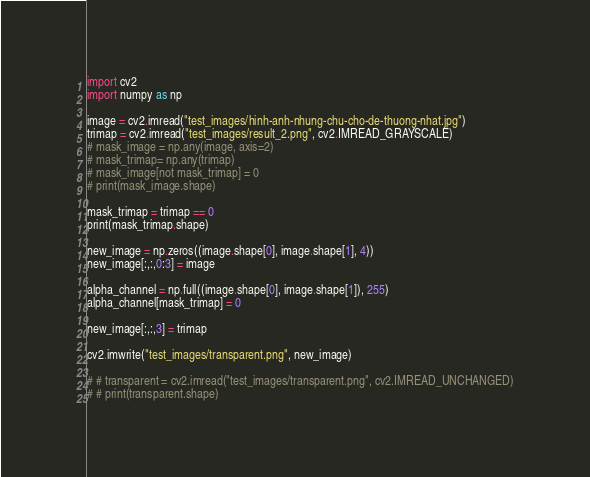Convert code to text. <code><loc_0><loc_0><loc_500><loc_500><_Python_>import cv2
import numpy as np

image = cv2.imread("test_images/hinh-anh-nhung-chu-cho-de-thuong-nhat.jpg")
trimap = cv2.imread("test_images/result_2.png", cv2.IMREAD_GRAYSCALE)
# mask_image = np.any(image, axis=2)
# mask_trimap= np.any(trimap)
# mask_image[not mask_trimap] = 0
# print(mask_image.shape)

mask_trimap = trimap == 0
print(mask_trimap.shape)

new_image = np.zeros((image.shape[0], image.shape[1], 4))
new_image[:,:,0:3] = image

alpha_channel = np.full((image.shape[0], image.shape[1]), 255)
alpha_channel[mask_trimap] = 0 

new_image[:,:,3] = trimap

cv2.imwrite("test_images/transparent.png", new_image)

# # transparent = cv2.imread("test_images/transparent.png", cv2.IMREAD_UNCHANGED)
# # print(transparent.shape)</code> 